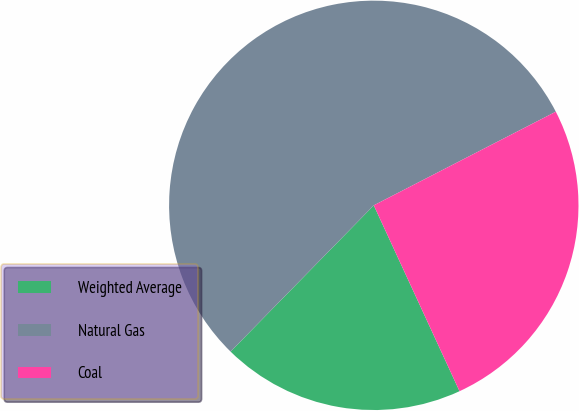Convert chart. <chart><loc_0><loc_0><loc_500><loc_500><pie_chart><fcel>Weighted Average<fcel>Natural Gas<fcel>Coal<nl><fcel>19.21%<fcel>55.1%<fcel>25.68%<nl></chart> 